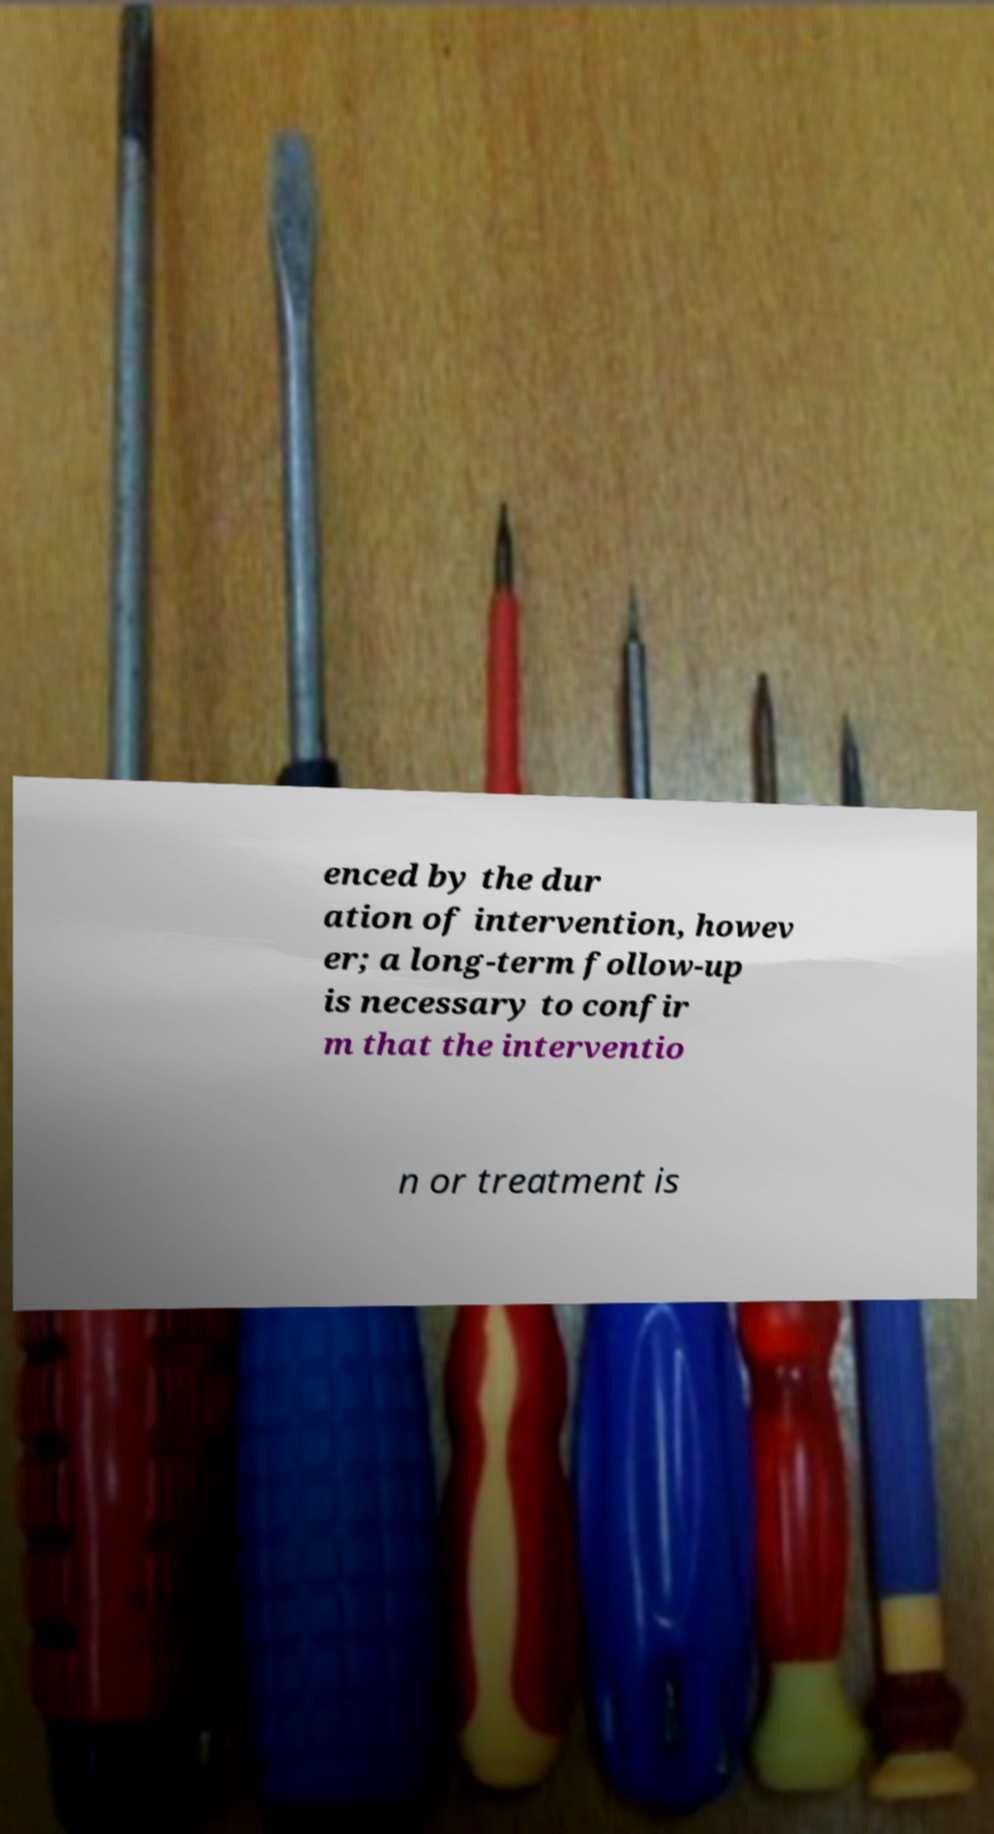Could you assist in decoding the text presented in this image and type it out clearly? enced by the dur ation of intervention, howev er; a long-term follow-up is necessary to confir m that the interventio n or treatment is 